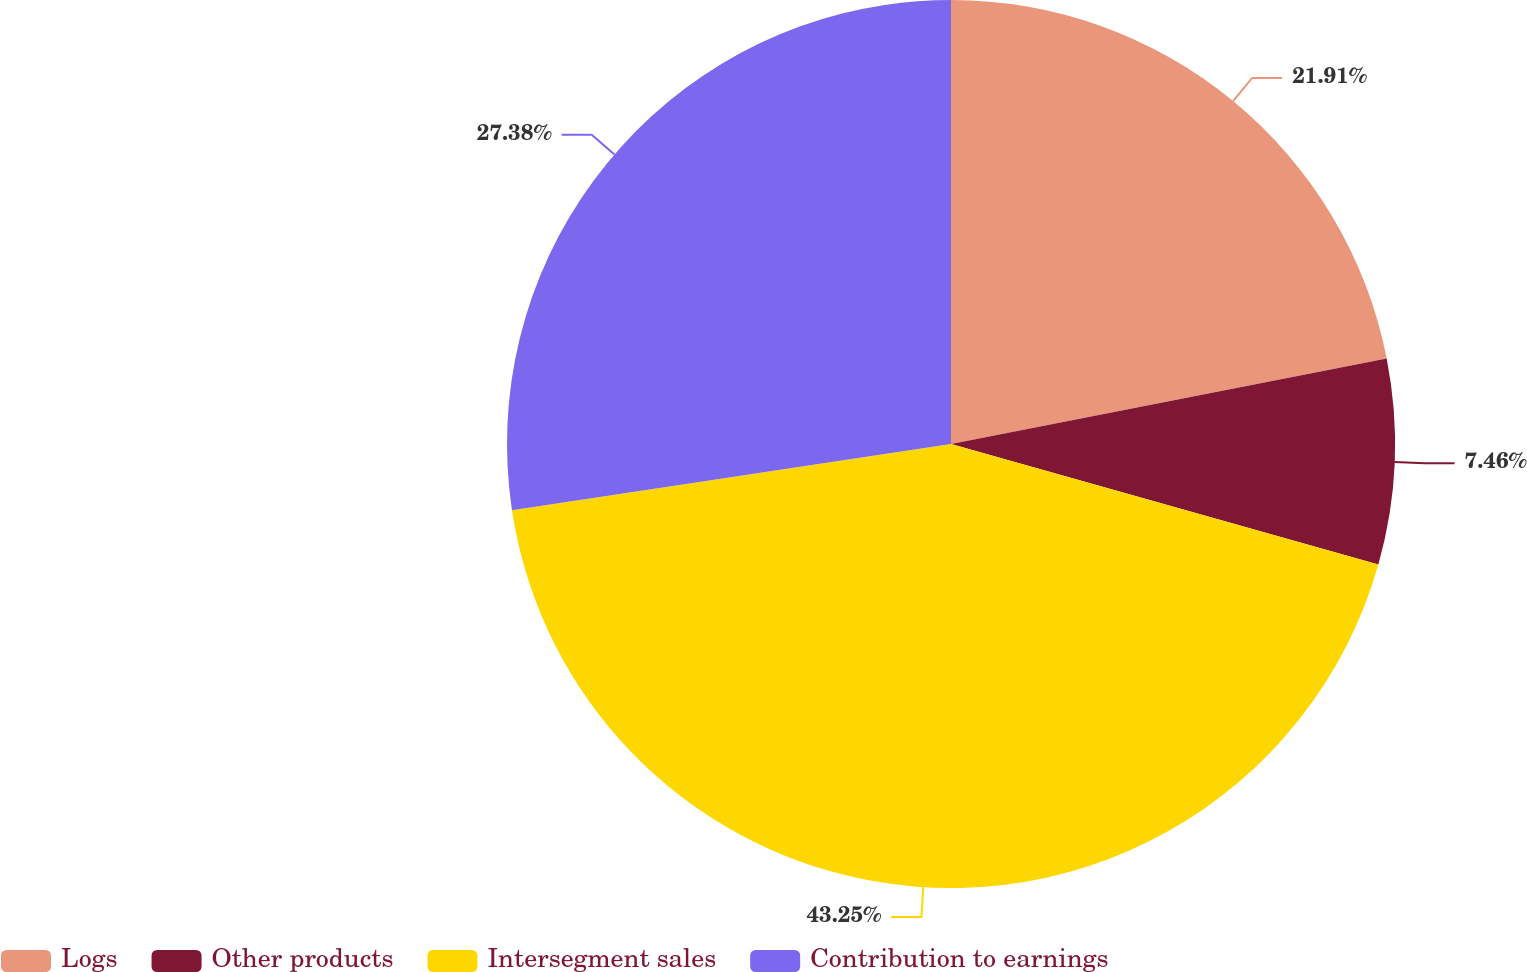<chart> <loc_0><loc_0><loc_500><loc_500><pie_chart><fcel>Logs<fcel>Other products<fcel>Intersegment sales<fcel>Contribution to earnings<nl><fcel>21.91%<fcel>7.46%<fcel>43.24%<fcel>27.38%<nl></chart> 